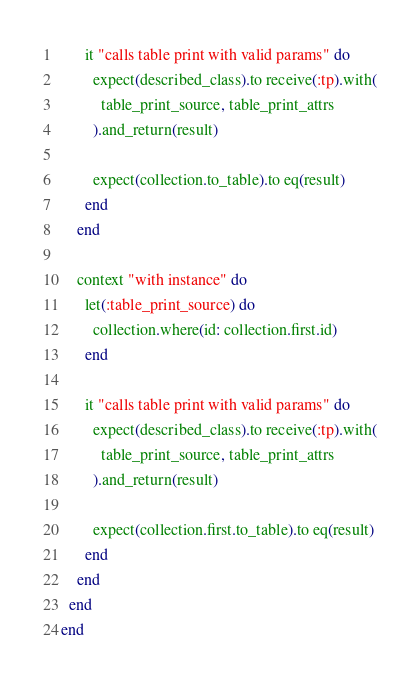<code> <loc_0><loc_0><loc_500><loc_500><_Ruby_>      it "calls table print with valid params" do
        expect(described_class).to receive(:tp).with(
          table_print_source, table_print_attrs
        ).and_return(result)

        expect(collection.to_table).to eq(result)
      end
    end

    context "with instance" do
      let(:table_print_source) do
        collection.where(id: collection.first.id)
      end

      it "calls table print with valid params" do
        expect(described_class).to receive(:tp).with(
          table_print_source, table_print_attrs
        ).and_return(result)

        expect(collection.first.to_table).to eq(result)
      end
    end
  end
end
</code> 